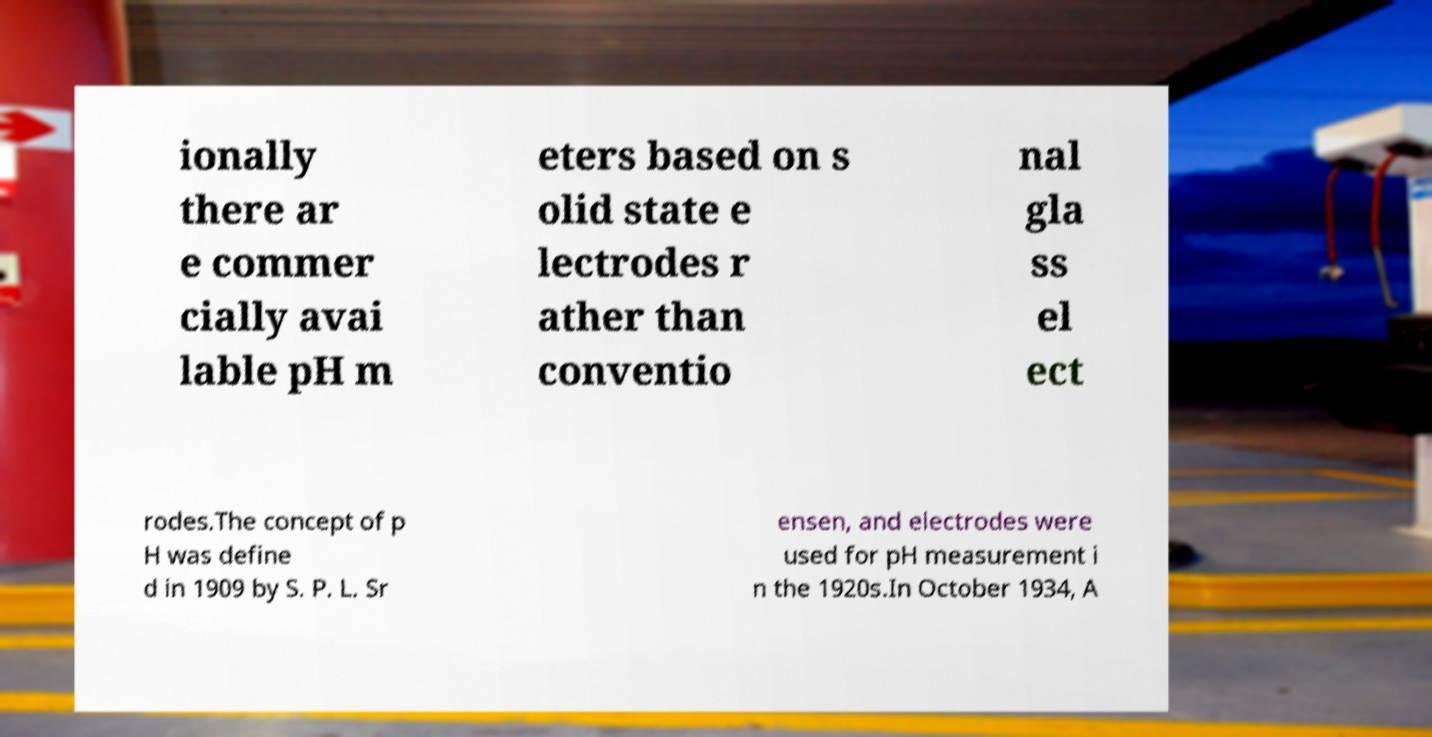Could you assist in decoding the text presented in this image and type it out clearly? ionally there ar e commer cially avai lable pH m eters based on s olid state e lectrodes r ather than conventio nal gla ss el ect rodes.The concept of p H was define d in 1909 by S. P. L. Sr ensen, and electrodes were used for pH measurement i n the 1920s.In October 1934, A 